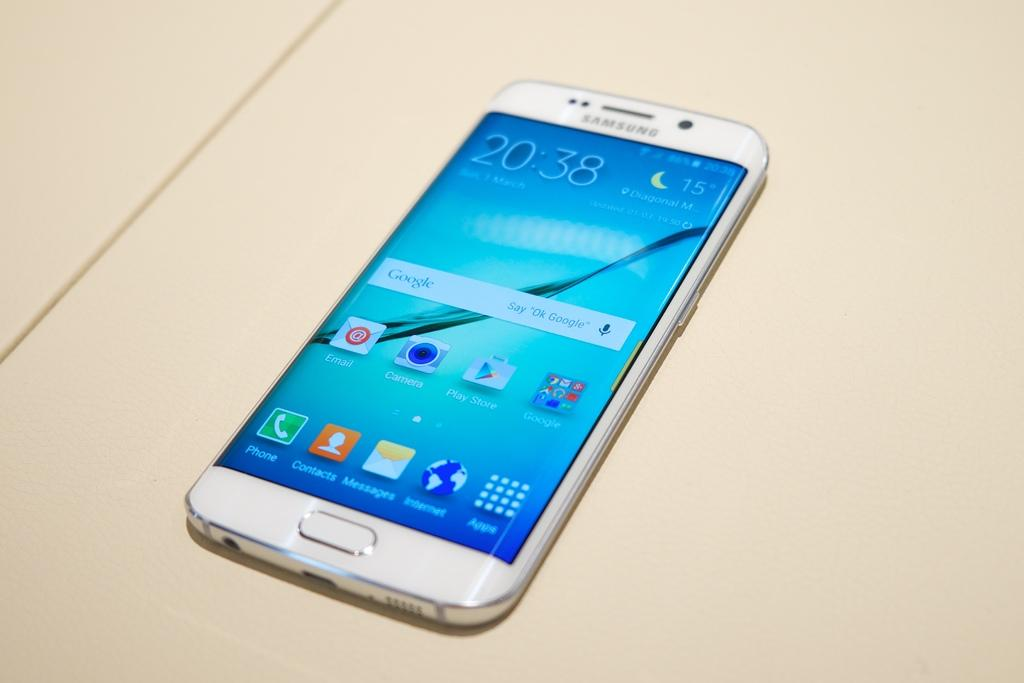<image>
Render a clear and concise summary of the photo. A white Iphone with apps on the front and the time 20:30. 